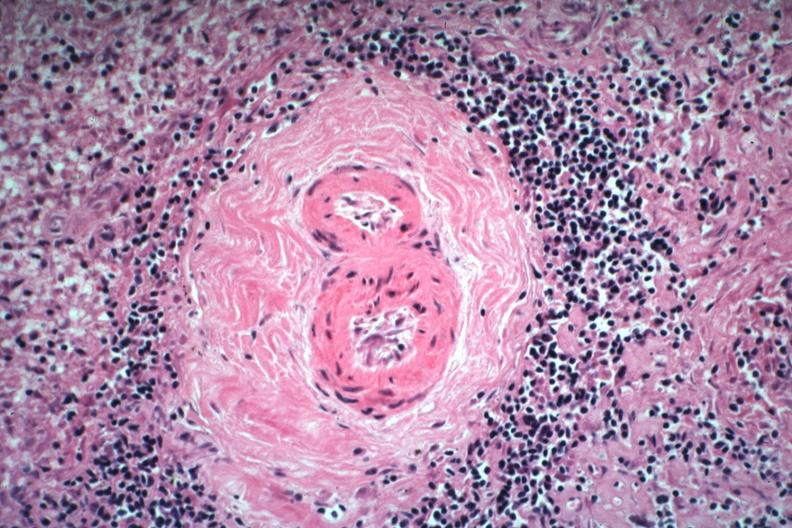s spleen present?
Answer the question using a single word or phrase. Yes 